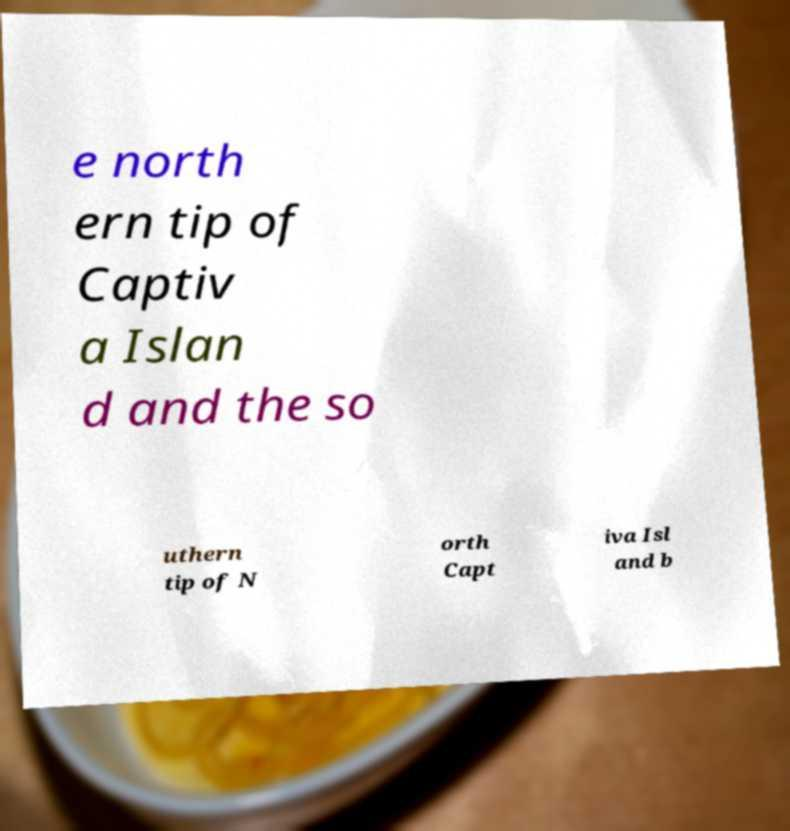For documentation purposes, I need the text within this image transcribed. Could you provide that? e north ern tip of Captiv a Islan d and the so uthern tip of N orth Capt iva Isl and b 